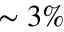<formula> <loc_0><loc_0><loc_500><loc_500>\sim 3 \%</formula> 